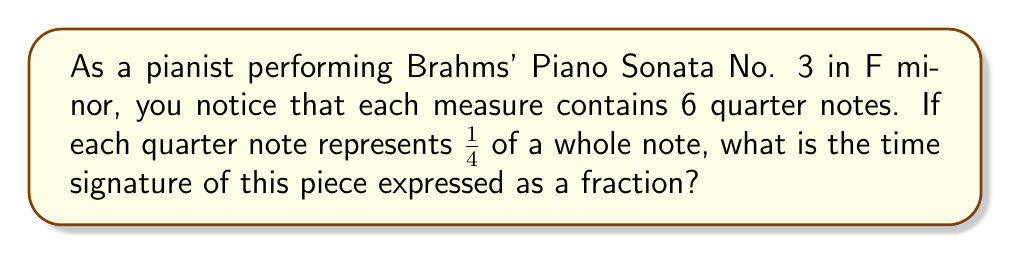What is the answer to this math problem? 1. First, we need to understand that the time signature is expressed as a fraction where:
   - The numerator represents the number of beats in each measure
   - The denominator represents the note value that gets one beat

2. We're told that each measure contains 6 quarter notes. This means the numerator of our fraction will be 6.

3. We're also told that each quarter note represents $\frac{1}{4}$ of a whole note. This means the denominator of our fraction will be 4.

4. Therefore, we can express the time signature as the fraction:

   $$\frac{6}{4}$$

5. This fraction represents 6 quarter notes per measure, which is equivalent to the time signature 6/4 in musical notation.
Answer: $\frac{6}{4}$ 